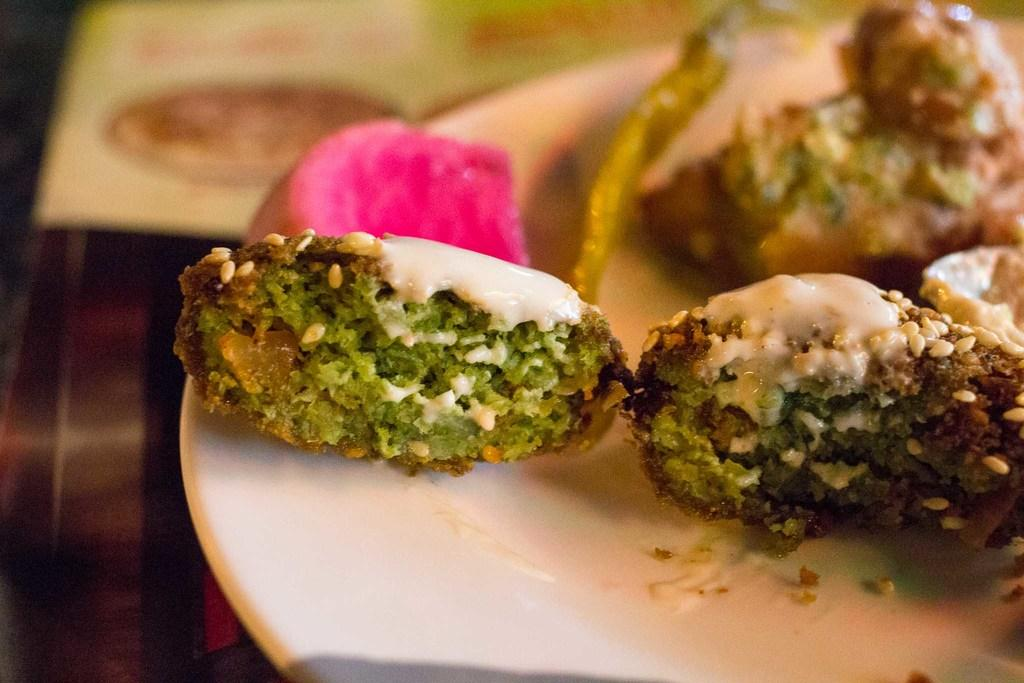What is on the plate that is visible in the image? There is a plate with food items in the image. Can you describe the background of the image? The background of the image is blurry. How many hands are visible in the image? There is no mention of hands in the provided facts, so we cannot determine the number of hands visible in the image. 